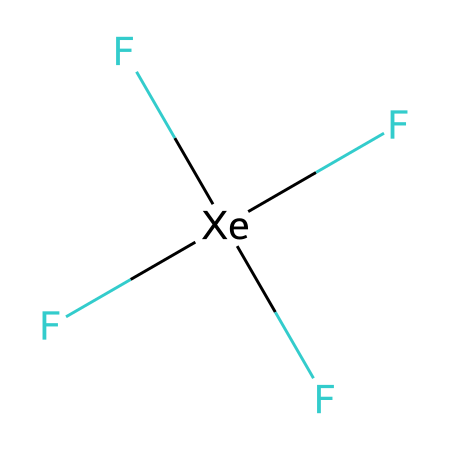What is the total number of fluorine atoms in xenon tetrafluoride? The chemical structure shows four fluorine atoms directly bonded to a central xenon atom, as indicated by the four 'F' symbols surrounding '[Xe]'.
Answer: four What is the central atom in this compound? The '[Xe]' notation represents the xenon atom, which is the central atom surrounded by the fluorine atoms in the structure.
Answer: xenon How many bonds are present in xenon tetrafluoride? Each fluorine atom forms a single bond with the xenon atom, and since there are four fluorine atoms, there are four bonds in total.
Answer: four Is xenon tetrafluoride polar or nonpolar? The symmetrical arrangement of the fluorine atoms around the central xenon suggests that the dipole moments cancel out, resulting in a nonpolar molecule.
Answer: nonpolar What is the hybridization of the xenon atom in xenon tetrafluoride? The xenon atom forms four equivalent sp³ hybrid orbitals to bond with four fluorine atoms, indicating its hybridization state.
Answer: sp³ Why is xenon tetrafluoride considered a hypervalent compound? Hypervalency occurs when an atom can accommodate more than eight electrons in its valence shell; here, xenon forms four bonds with fluorine, contributing a total of eight electrons from the four bonding pairs.
Answer: hypervalent What is the molecular geometry of xenon tetrafluoride? The arrangement of four fluorine atoms around the central xenon atom leads to a tetrahedral geometry.
Answer: tetrahedral 